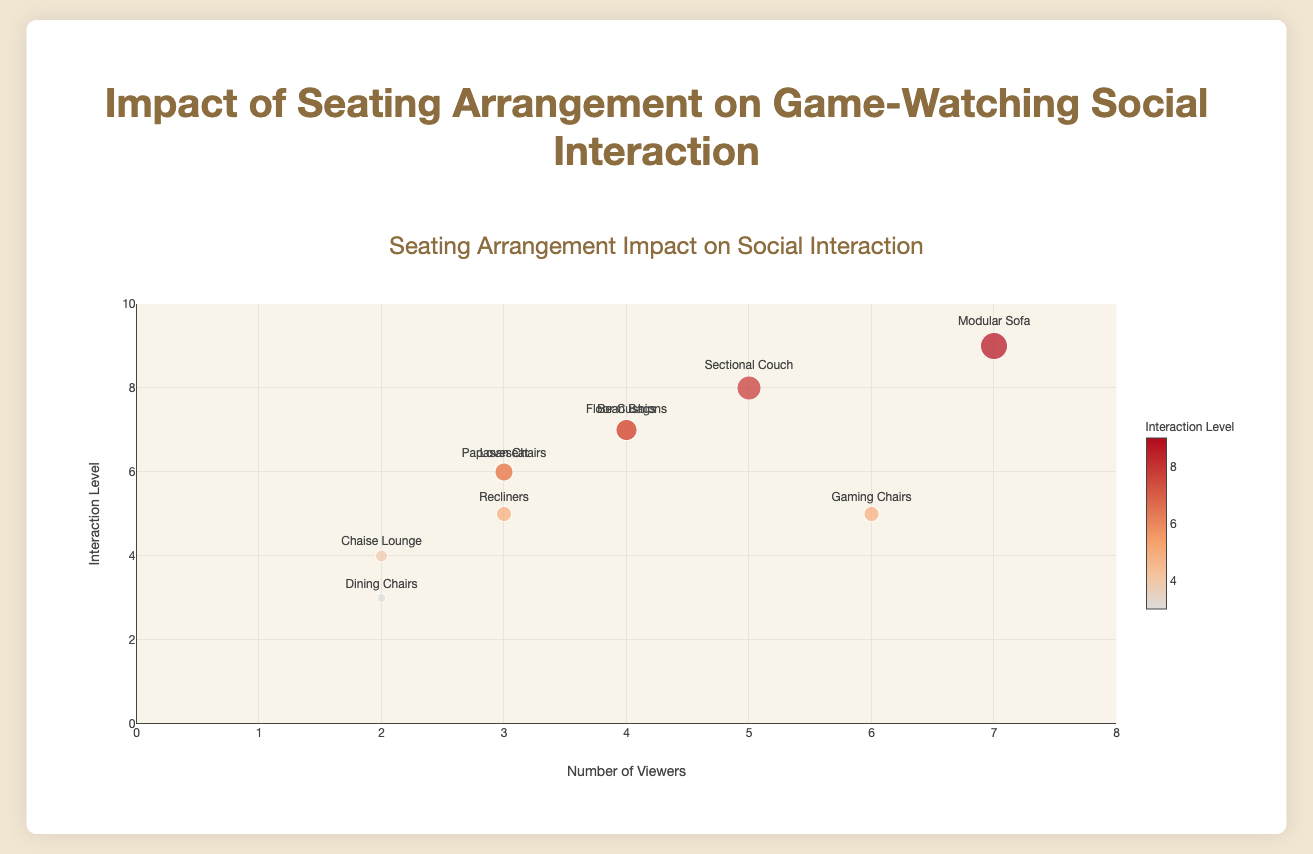What's the title of the plot? The title of the plot appears at the top and states "Seating Arrangement Impact on Social Interaction" which indicates the main focus of the figure.
Answer: Seating Arrangement Impact on Social Interaction How many data points represent an interaction level of 5? There are two markers on the vertical axis at position 5, which shows that two seating arrangements have an interaction level of 5.
Answer: 2 Which seating arrangement has the highest interaction level and how many viewers does it have? The highest interaction level is 9, associated with the "Modular Sofa" seating arrangement, which has 7 viewers. This information is observed by locating the highest point on the y-axis and checking corresponding labels.
Answer: Modular Sofa, 7 viewers Which seating arrangements share the same number of viewers but differ in interaction levels? The seating arrangements "Bean Bags" and "Floor Cushions" both have 4 viewers but differ in interaction levels (7 for "Floor Cushions" and 7 for "Bean Bags"). Similarly, "Recliners" and "Papasan Chairs" have 3 viewers each but differ in interaction levels (5 for "Recliners" and 6 for "Papasan Chairs").
Answer: Bean Bags and Floor Cushions or Recliners and Papasan Chairs Compare the interaction levels of "Sectional Couch" and "Gaming Chairs". Which has a higher level and by how much? The interaction level of "Sectional Couch" is 8, while "Gaming Chairs" is 5. The difference between them is 8 - 5 = 3, indicating "Sectional Couch" has a higher interaction level by 3 units.
Answer: Sectional Couch by 3 What's the range of interaction levels in the plot? The range of interaction levels can be observed from the lowest to the highest point on the y-axis, spanning from 3 to 9.
Answer: 3 to 9 What is the average number of viewers for seating arrangements with an interaction level greater than or equal to 6? The seating arrangements with interaction levels ≥ 6 are "Sectional Couch" (5 viewers), "Bean Bags" (4 viewers), "Loveseat" (3 viewers), "Floor Cushions" (4 viewers), "Modular Sofa" (7 viewers), and "Papasan Chairs" (3 viewers). Summing the viewers (5+4+3+4+7+3) = 26. There are 6 seating arrangements, so the average is 26/6 = 4.33.
Answer: 4.33 Which seating arrangement in a "Large House" had the highest interaction level, and what was its value? Looking for seating arrangements in a "Large House", we see that "Floor Cushions" in a "Large House" has an interaction level of 7, which is its highest interaction level in this living space type.
Answer: Floor Cushions, 7 How does the interaction level of "Chaise Lounge" compare to that of "Dining Chairs"? "Chaise Lounge" has an interaction level of 4, while "Dining Chairs" has an interaction level of 3. Therefore, "Chaise Lounge" has a higher interaction level by 1 unit.
Answer: Chaise Lounge is higher by 1 